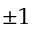<formula> <loc_0><loc_0><loc_500><loc_500>\pm 1</formula> 